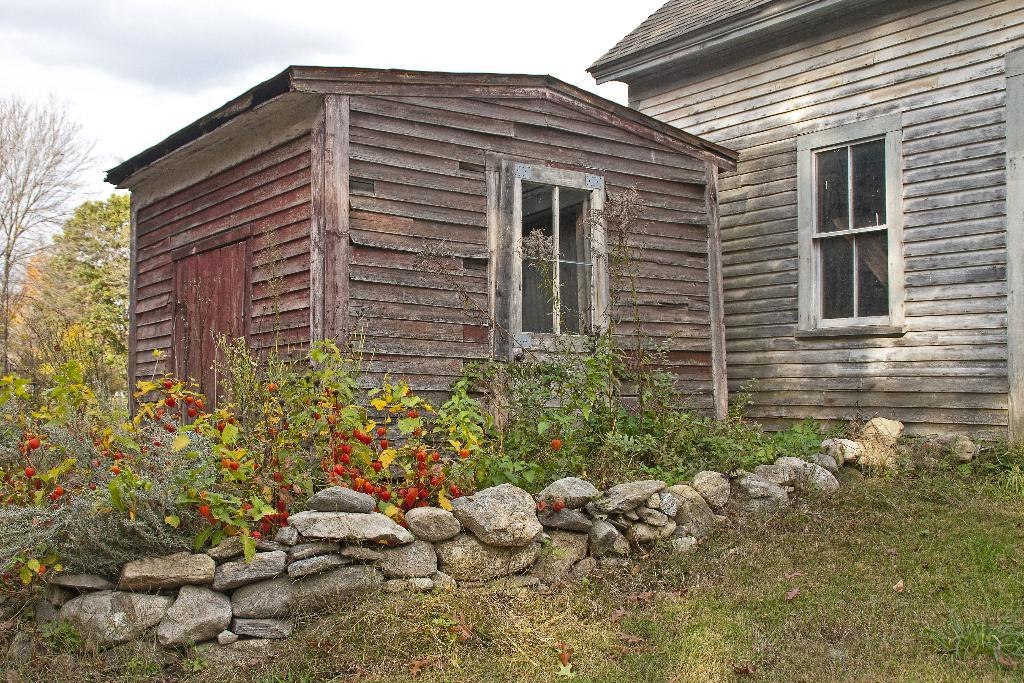How many houses can be seen in the image? There are 2 houses in the image. What type of vegetation is present in the image? There are plants and trees in the image. What is the ground made of in the image? There is grass and stones in the image. What can be seen in the background of the image? There are trees and the sky visible in the background of the image. What type of chicken can be seen in the image? There is no chicken present in the image. How many mouths can be seen in the image? There are no mouths visible in the image. 